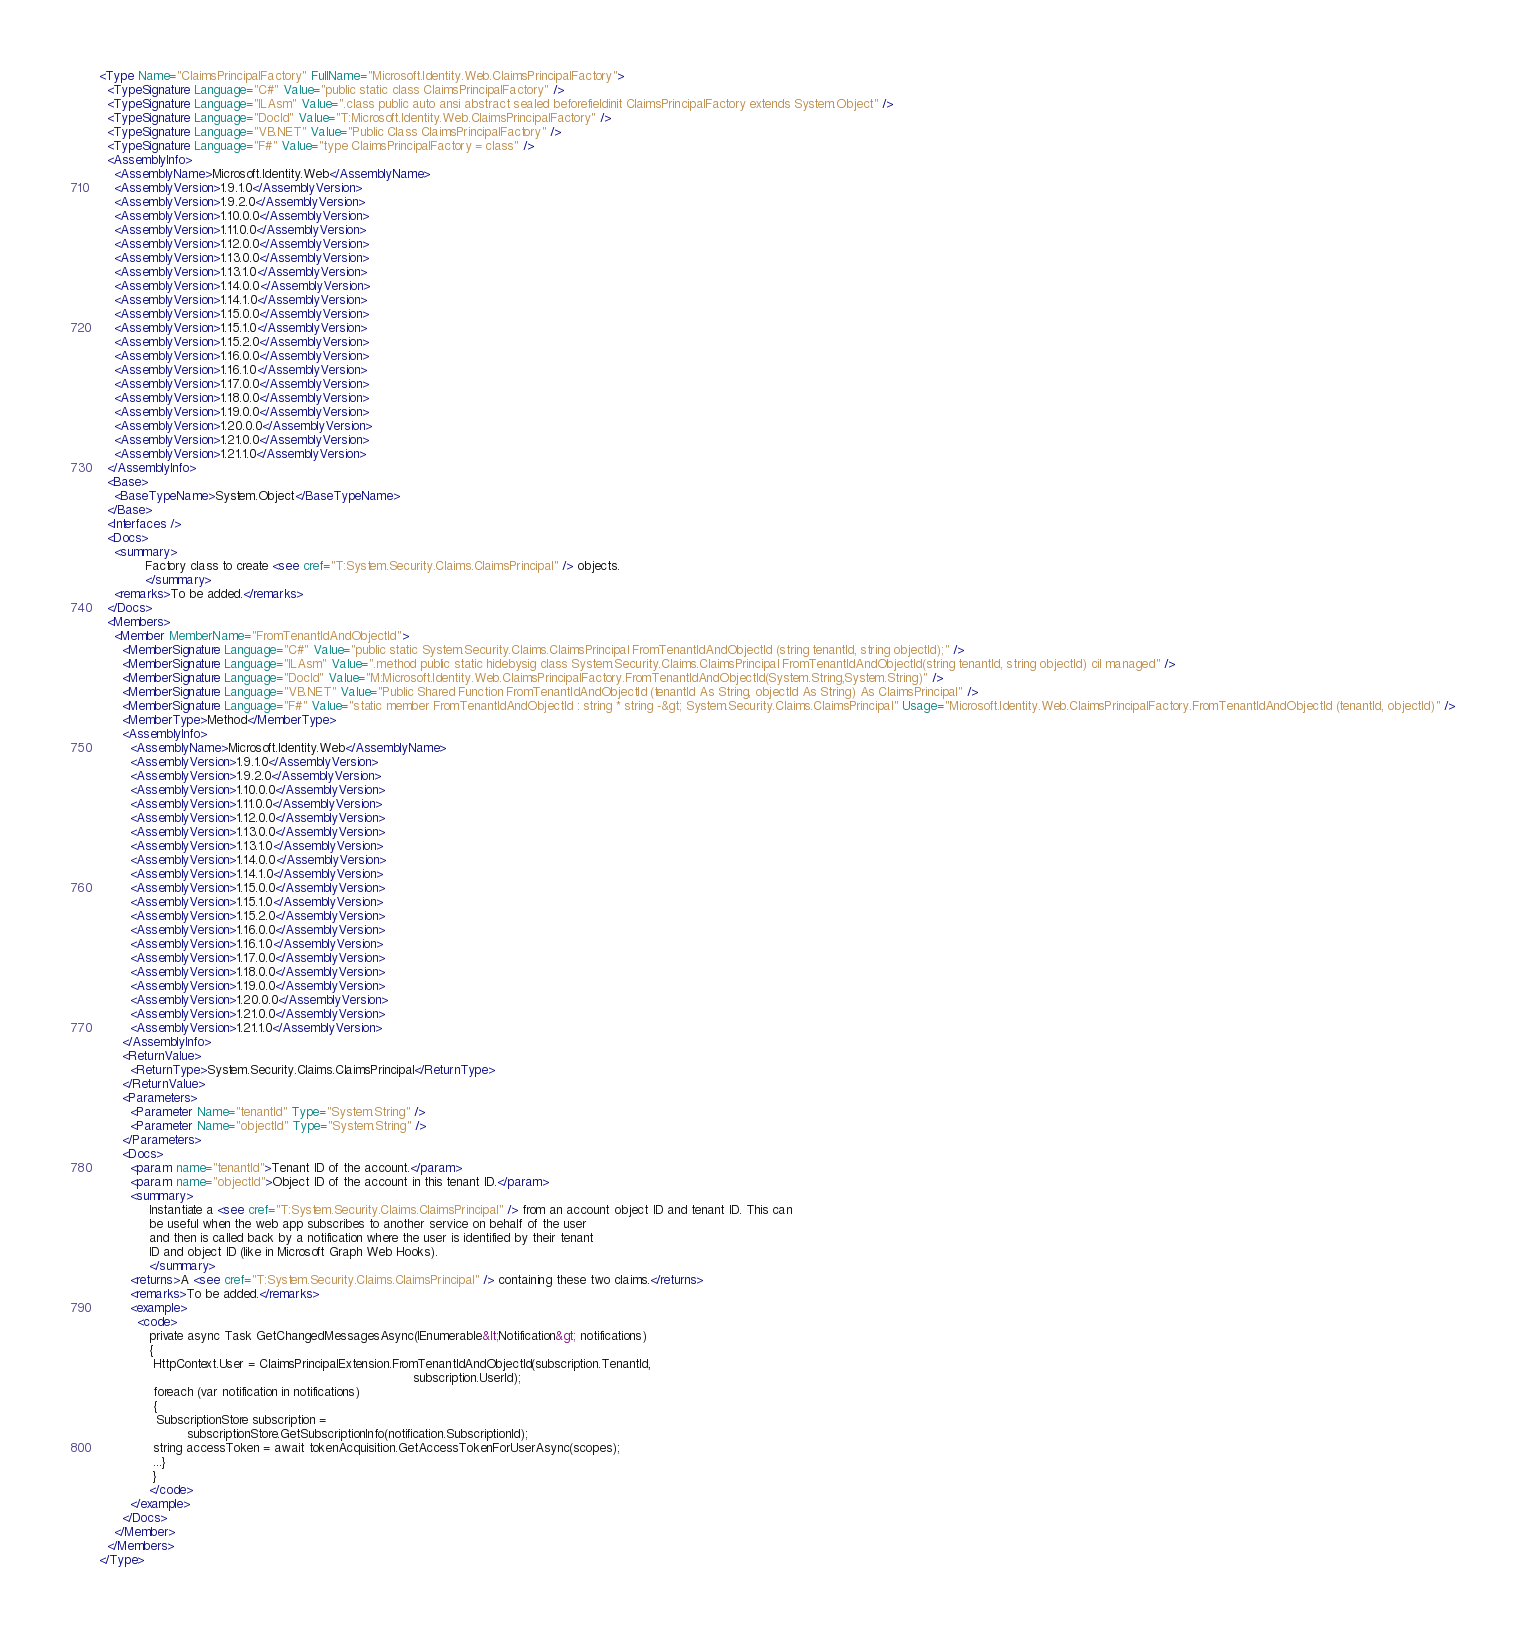Convert code to text. <code><loc_0><loc_0><loc_500><loc_500><_XML_><Type Name="ClaimsPrincipalFactory" FullName="Microsoft.Identity.Web.ClaimsPrincipalFactory">
  <TypeSignature Language="C#" Value="public static class ClaimsPrincipalFactory" />
  <TypeSignature Language="ILAsm" Value=".class public auto ansi abstract sealed beforefieldinit ClaimsPrincipalFactory extends System.Object" />
  <TypeSignature Language="DocId" Value="T:Microsoft.Identity.Web.ClaimsPrincipalFactory" />
  <TypeSignature Language="VB.NET" Value="Public Class ClaimsPrincipalFactory" />
  <TypeSignature Language="F#" Value="type ClaimsPrincipalFactory = class" />
  <AssemblyInfo>
    <AssemblyName>Microsoft.Identity.Web</AssemblyName>
    <AssemblyVersion>1.9.1.0</AssemblyVersion>
    <AssemblyVersion>1.9.2.0</AssemblyVersion>
    <AssemblyVersion>1.10.0.0</AssemblyVersion>
    <AssemblyVersion>1.11.0.0</AssemblyVersion>
    <AssemblyVersion>1.12.0.0</AssemblyVersion>
    <AssemblyVersion>1.13.0.0</AssemblyVersion>
    <AssemblyVersion>1.13.1.0</AssemblyVersion>
    <AssemblyVersion>1.14.0.0</AssemblyVersion>
    <AssemblyVersion>1.14.1.0</AssemblyVersion>
    <AssemblyVersion>1.15.0.0</AssemblyVersion>
    <AssemblyVersion>1.15.1.0</AssemblyVersion>
    <AssemblyVersion>1.15.2.0</AssemblyVersion>
    <AssemblyVersion>1.16.0.0</AssemblyVersion>
    <AssemblyVersion>1.16.1.0</AssemblyVersion>
    <AssemblyVersion>1.17.0.0</AssemblyVersion>
    <AssemblyVersion>1.18.0.0</AssemblyVersion>
    <AssemblyVersion>1.19.0.0</AssemblyVersion>
    <AssemblyVersion>1.20.0.0</AssemblyVersion>
    <AssemblyVersion>1.21.0.0</AssemblyVersion>
    <AssemblyVersion>1.21.1.0</AssemblyVersion>
  </AssemblyInfo>
  <Base>
    <BaseTypeName>System.Object</BaseTypeName>
  </Base>
  <Interfaces />
  <Docs>
    <summary>
            Factory class to create <see cref="T:System.Security.Claims.ClaimsPrincipal" /> objects.
            </summary>
    <remarks>To be added.</remarks>
  </Docs>
  <Members>
    <Member MemberName="FromTenantIdAndObjectId">
      <MemberSignature Language="C#" Value="public static System.Security.Claims.ClaimsPrincipal FromTenantIdAndObjectId (string tenantId, string objectId);" />
      <MemberSignature Language="ILAsm" Value=".method public static hidebysig class System.Security.Claims.ClaimsPrincipal FromTenantIdAndObjectId(string tenantId, string objectId) cil managed" />
      <MemberSignature Language="DocId" Value="M:Microsoft.Identity.Web.ClaimsPrincipalFactory.FromTenantIdAndObjectId(System.String,System.String)" />
      <MemberSignature Language="VB.NET" Value="Public Shared Function FromTenantIdAndObjectId (tenantId As String, objectId As String) As ClaimsPrincipal" />
      <MemberSignature Language="F#" Value="static member FromTenantIdAndObjectId : string * string -&gt; System.Security.Claims.ClaimsPrincipal" Usage="Microsoft.Identity.Web.ClaimsPrincipalFactory.FromTenantIdAndObjectId (tenantId, objectId)" />
      <MemberType>Method</MemberType>
      <AssemblyInfo>
        <AssemblyName>Microsoft.Identity.Web</AssemblyName>
        <AssemblyVersion>1.9.1.0</AssemblyVersion>
        <AssemblyVersion>1.9.2.0</AssemblyVersion>
        <AssemblyVersion>1.10.0.0</AssemblyVersion>
        <AssemblyVersion>1.11.0.0</AssemblyVersion>
        <AssemblyVersion>1.12.0.0</AssemblyVersion>
        <AssemblyVersion>1.13.0.0</AssemblyVersion>
        <AssemblyVersion>1.13.1.0</AssemblyVersion>
        <AssemblyVersion>1.14.0.0</AssemblyVersion>
        <AssemblyVersion>1.14.1.0</AssemblyVersion>
        <AssemblyVersion>1.15.0.0</AssemblyVersion>
        <AssemblyVersion>1.15.1.0</AssemblyVersion>
        <AssemblyVersion>1.15.2.0</AssemblyVersion>
        <AssemblyVersion>1.16.0.0</AssemblyVersion>
        <AssemblyVersion>1.16.1.0</AssemblyVersion>
        <AssemblyVersion>1.17.0.0</AssemblyVersion>
        <AssemblyVersion>1.18.0.0</AssemblyVersion>
        <AssemblyVersion>1.19.0.0</AssemblyVersion>
        <AssemblyVersion>1.20.0.0</AssemblyVersion>
        <AssemblyVersion>1.21.0.0</AssemblyVersion>
        <AssemblyVersion>1.21.1.0</AssemblyVersion>
      </AssemblyInfo>
      <ReturnValue>
        <ReturnType>System.Security.Claims.ClaimsPrincipal</ReturnType>
      </ReturnValue>
      <Parameters>
        <Parameter Name="tenantId" Type="System.String" />
        <Parameter Name="objectId" Type="System.String" />
      </Parameters>
      <Docs>
        <param name="tenantId">Tenant ID of the account.</param>
        <param name="objectId">Object ID of the account in this tenant ID.</param>
        <summary>
             Instantiate a <see cref="T:System.Security.Claims.ClaimsPrincipal" /> from an account object ID and tenant ID. This can
             be useful when the web app subscribes to another service on behalf of the user
             and then is called back by a notification where the user is identified by their tenant
             ID and object ID (like in Microsoft Graph Web Hooks).
             </summary>
        <returns>A <see cref="T:System.Security.Claims.ClaimsPrincipal" /> containing these two claims.</returns>
        <remarks>To be added.</remarks>
        <example>
          <code>
             private async Task GetChangedMessagesAsync(IEnumerable&lt;Notification&gt; notifications)
             {
              HttpContext.User = ClaimsPrincipalExtension.FromTenantIdAndObjectId(subscription.TenantId,
                                                                                  subscription.UserId);
              foreach (var notification in notifications)
              {
               SubscriptionStore subscription =
                       subscriptionStore.GetSubscriptionInfo(notification.SubscriptionId);
              string accessToken = await tokenAcquisition.GetAccessTokenForUserAsync(scopes);
              ...}
              }
             </code>
        </example>
      </Docs>
    </Member>
  </Members>
</Type>
</code> 